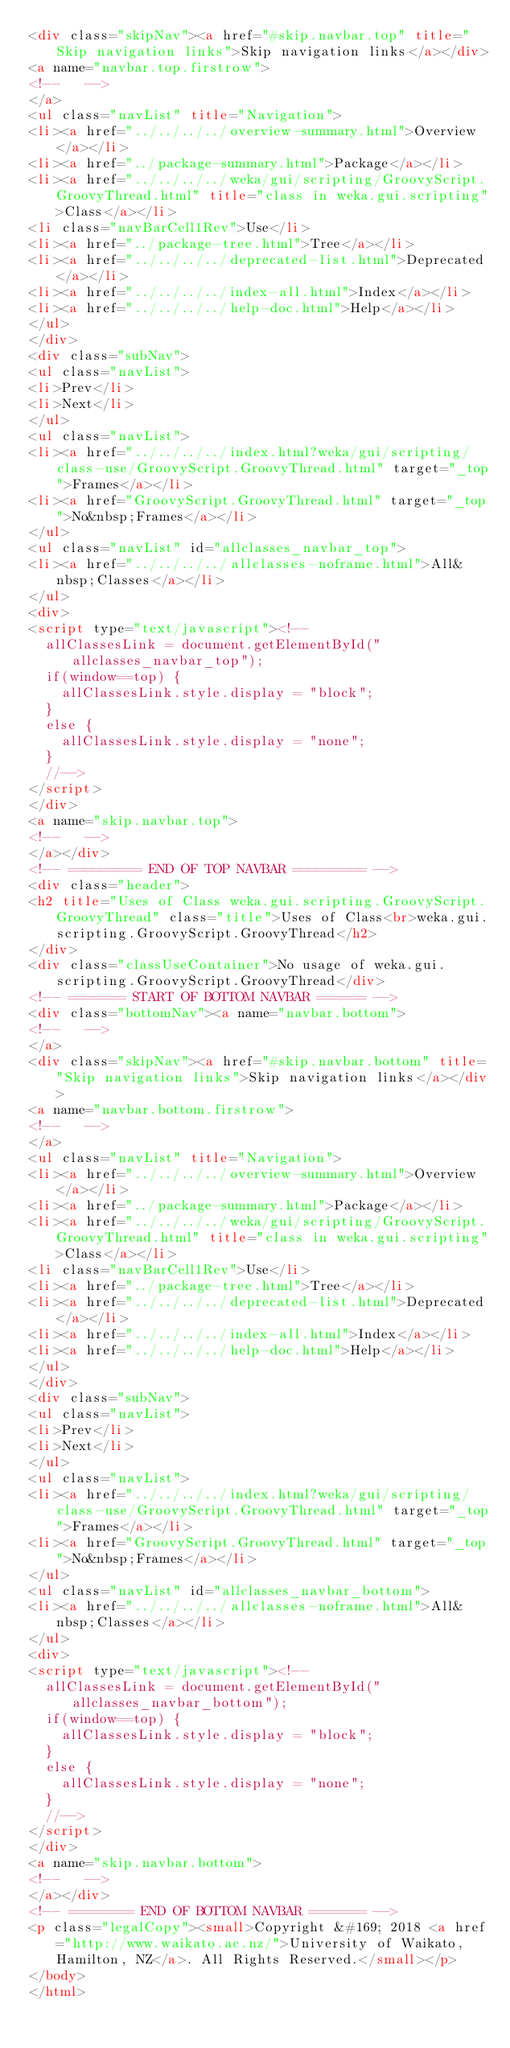Convert code to text. <code><loc_0><loc_0><loc_500><loc_500><_HTML_><div class="skipNav"><a href="#skip.navbar.top" title="Skip navigation links">Skip navigation links</a></div>
<a name="navbar.top.firstrow">
<!--   -->
</a>
<ul class="navList" title="Navigation">
<li><a href="../../../../overview-summary.html">Overview</a></li>
<li><a href="../package-summary.html">Package</a></li>
<li><a href="../../../../weka/gui/scripting/GroovyScript.GroovyThread.html" title="class in weka.gui.scripting">Class</a></li>
<li class="navBarCell1Rev">Use</li>
<li><a href="../package-tree.html">Tree</a></li>
<li><a href="../../../../deprecated-list.html">Deprecated</a></li>
<li><a href="../../../../index-all.html">Index</a></li>
<li><a href="../../../../help-doc.html">Help</a></li>
</ul>
</div>
<div class="subNav">
<ul class="navList">
<li>Prev</li>
<li>Next</li>
</ul>
<ul class="navList">
<li><a href="../../../../index.html?weka/gui/scripting/class-use/GroovyScript.GroovyThread.html" target="_top">Frames</a></li>
<li><a href="GroovyScript.GroovyThread.html" target="_top">No&nbsp;Frames</a></li>
</ul>
<ul class="navList" id="allclasses_navbar_top">
<li><a href="../../../../allclasses-noframe.html">All&nbsp;Classes</a></li>
</ul>
<div>
<script type="text/javascript"><!--
  allClassesLink = document.getElementById("allclasses_navbar_top");
  if(window==top) {
    allClassesLink.style.display = "block";
  }
  else {
    allClassesLink.style.display = "none";
  }
  //-->
</script>
</div>
<a name="skip.navbar.top">
<!--   -->
</a></div>
<!-- ========= END OF TOP NAVBAR ========= -->
<div class="header">
<h2 title="Uses of Class weka.gui.scripting.GroovyScript.GroovyThread" class="title">Uses of Class<br>weka.gui.scripting.GroovyScript.GroovyThread</h2>
</div>
<div class="classUseContainer">No usage of weka.gui.scripting.GroovyScript.GroovyThread</div>
<!-- ======= START OF BOTTOM NAVBAR ====== -->
<div class="bottomNav"><a name="navbar.bottom">
<!--   -->
</a>
<div class="skipNav"><a href="#skip.navbar.bottom" title="Skip navigation links">Skip navigation links</a></div>
<a name="navbar.bottom.firstrow">
<!--   -->
</a>
<ul class="navList" title="Navigation">
<li><a href="../../../../overview-summary.html">Overview</a></li>
<li><a href="../package-summary.html">Package</a></li>
<li><a href="../../../../weka/gui/scripting/GroovyScript.GroovyThread.html" title="class in weka.gui.scripting">Class</a></li>
<li class="navBarCell1Rev">Use</li>
<li><a href="../package-tree.html">Tree</a></li>
<li><a href="../../../../deprecated-list.html">Deprecated</a></li>
<li><a href="../../../../index-all.html">Index</a></li>
<li><a href="../../../../help-doc.html">Help</a></li>
</ul>
</div>
<div class="subNav">
<ul class="navList">
<li>Prev</li>
<li>Next</li>
</ul>
<ul class="navList">
<li><a href="../../../../index.html?weka/gui/scripting/class-use/GroovyScript.GroovyThread.html" target="_top">Frames</a></li>
<li><a href="GroovyScript.GroovyThread.html" target="_top">No&nbsp;Frames</a></li>
</ul>
<ul class="navList" id="allclasses_navbar_bottom">
<li><a href="../../../../allclasses-noframe.html">All&nbsp;Classes</a></li>
</ul>
<div>
<script type="text/javascript"><!--
  allClassesLink = document.getElementById("allclasses_navbar_bottom");
  if(window==top) {
    allClassesLink.style.display = "block";
  }
  else {
    allClassesLink.style.display = "none";
  }
  //-->
</script>
</div>
<a name="skip.navbar.bottom">
<!--   -->
</a></div>
<!-- ======== END OF BOTTOM NAVBAR ======= -->
<p class="legalCopy"><small>Copyright &#169; 2018 <a href="http://www.waikato.ac.nz/">University of Waikato, Hamilton, NZ</a>. All Rights Reserved.</small></p>
</body>
</html>
</code> 